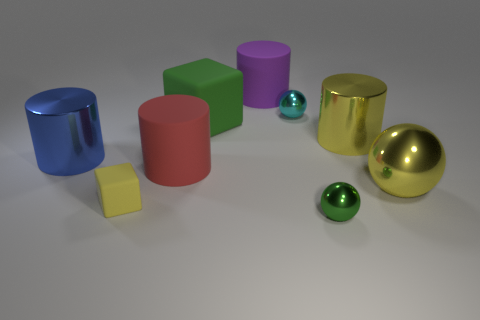Subtract all cylinders. How many objects are left? 5 Subtract all tiny yellow matte objects. Subtract all large cylinders. How many objects are left? 4 Add 3 green rubber things. How many green rubber things are left? 4 Add 5 yellow spheres. How many yellow spheres exist? 6 Subtract 0 cyan cubes. How many objects are left? 9 